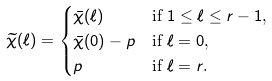Convert formula to latex. <formula><loc_0><loc_0><loc_500><loc_500>\widetilde { \chi } ( \ell ) & = \begin{cases} \bar { \chi } ( \ell ) & \text {if $1\leq\ell\leq r-1$,} \\ \bar { \chi } ( 0 ) - p & \text {if $\ell=0$,} \\ p & \text {if $\ell=r$.} \end{cases}</formula> 